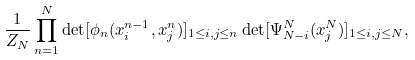<formula> <loc_0><loc_0><loc_500><loc_500>\frac { 1 } { Z _ { N } } \prod _ { n = 1 } ^ { N } \det [ \phi _ { n } ( x _ { i } ^ { n - 1 } , x _ { j } ^ { n } ) ] _ { 1 \leq i , j \leq n } \det [ \Psi _ { N - i } ^ { N } ( x _ { j } ^ { N } ) ] _ { 1 \leq i , j \leq N } ,</formula> 